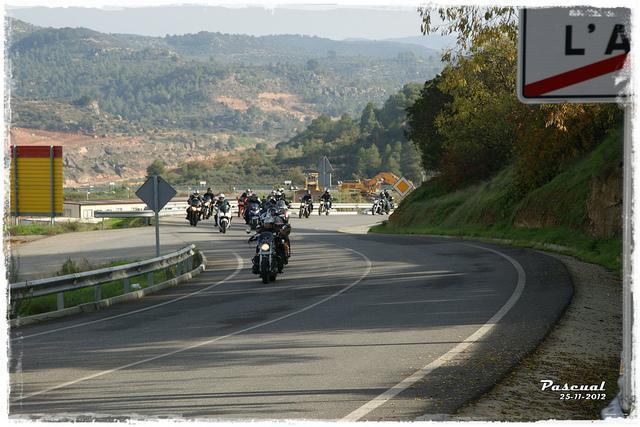How many people have a umbrella in the picture?
Give a very brief answer. 0. 